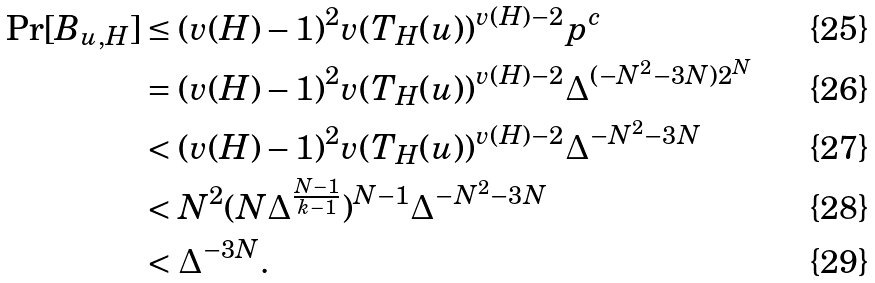Convert formula to latex. <formula><loc_0><loc_0><loc_500><loc_500>\Pr [ B _ { u , H } ] & \leq ( v ( H ) - 1 ) ^ { 2 } v ( T _ { H } ( u ) ) ^ { v ( H ) - 2 } p ^ { c } \\ & = ( v ( H ) - 1 ) ^ { 2 } v ( T _ { H } ( u ) ) ^ { v ( H ) - 2 } \Delta ^ { ( - N ^ { 2 } - 3 N ) 2 ^ { N } } \\ & < ( v ( H ) - 1 ) ^ { 2 } v ( T _ { H } ( u ) ) ^ { v ( H ) - 2 } \Delta ^ { - N ^ { 2 } - 3 N } \\ & < N ^ { 2 } ( N \Delta ^ { \frac { N - 1 } { k - 1 } } ) ^ { N - 1 } \Delta ^ { - N ^ { 2 } - 3 N } \\ & < \Delta ^ { - 3 N } .</formula> 